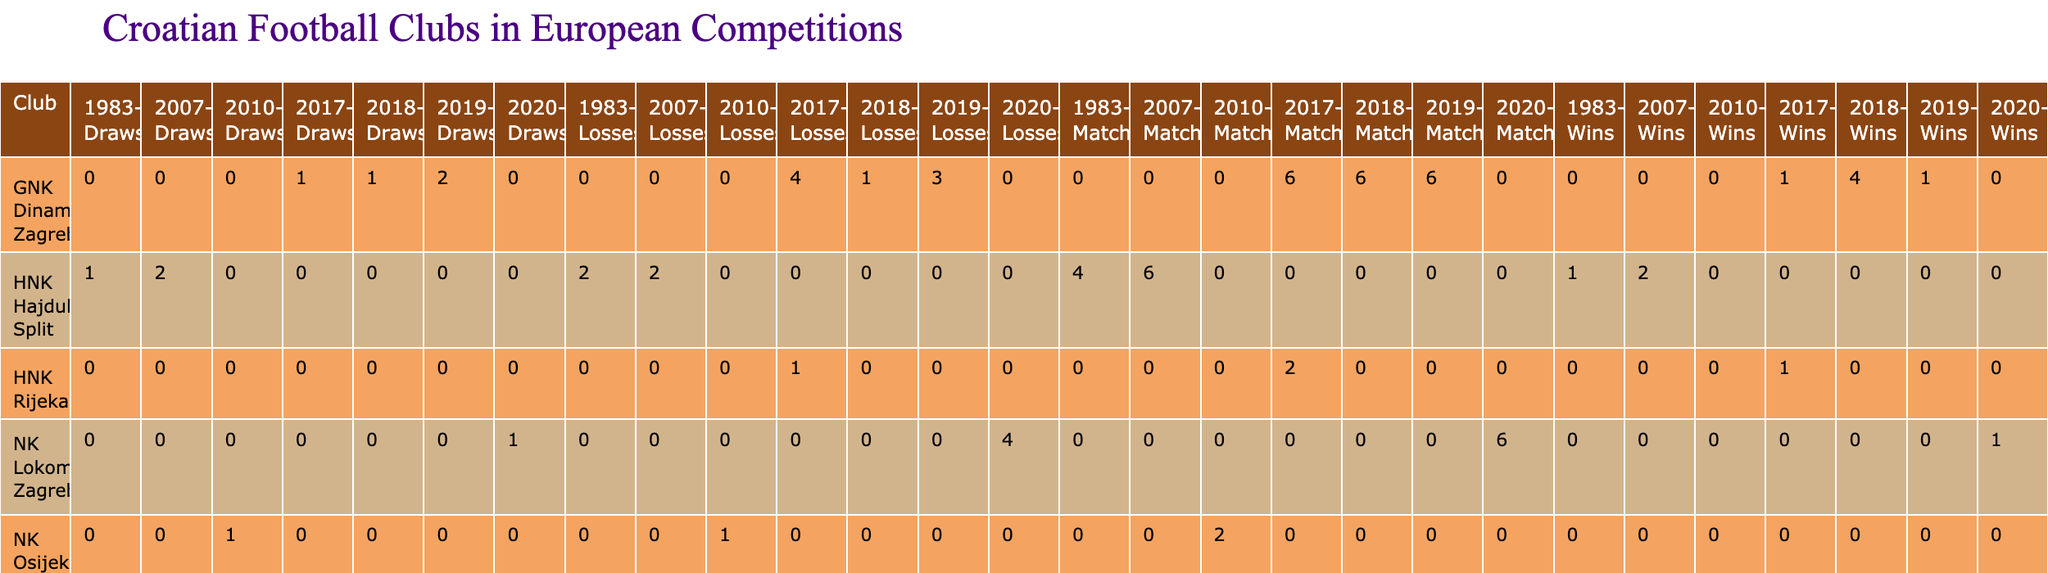What is the total number of matches played by GNK Dinamo Zagreb in the 2018-2019 UEFA Europa League? The table shows that in the 2018-2019 UEFA Europa League, GNK Dinamo Zagreb played a total of 6 matches.
Answer: 6 Which club had the most wins in their group stage matches in the 2019-2020 UEFA Champions League? In the 2019-2020 UEFA Champions League, GNK Dinamo Zagreb had 1 win in the group stage, which is noted in the table. This is the only entry in this specific competition for that season, so there are no clubs with more wins.
Answer: 1 How many total losses did HNK Hajduk Split have across their European competitions in the data presented? The table shows that HNK Hajduk Split had 2 losses in the 2007-2008 UEFA Cup and no other entries, leading to a total of 2 losses overall.
Answer: 2 Is it true that NK Osijek won any matches in their 2010-2011 UEFA Europa League qualification? The table indicates that NK Osijek did not win any matches, as they have 0 wins logged.
Answer: Yes What was the average number of draws for HNK Rijeka in European competitions based on the data? HNK Rijeka played 2 matches in the 2017-2018 UEFA Europa League with 0 draws and no other entries. Therefore, the average is calculated as (0 draws) / (1 competition) = 0.
Answer: 0 How many goals did GNK Dinamo Zagreb score in the UEFA Champions League group stage of 2017-2018 compared to their UEFA Europa League performance in 2018-2019? In the 2017-2018 UEFA Champions League group stage, GNK Dinamo Zagreb scored 4 goals, while in the 2018-2019 UEFA Europa League, they scored 14 goals. Thus, the goals scored in UEFA Europa League is 10 more than that in UEFA Champions League.
Answer: 10 more Which club had the best goal difference in the 2018-2019 UEFA Europa League group stage? In 2018-2019, GNK Dinamo Zagreb scored 14 goals and conceded 5, giving them a goal difference of +9. No other club's goal difference in that competition surpasses this.
Answer: GNK Dinamo Zagreb What was the stage reached by HNK Hajduk Split in the European Cup of 1983-1984? According to the table, HNK Hajduk Split reached the Quarter-Finals stage in the European Cup of 1983-1984.
Answer: Quarter-Finals What is the overall record of HNK Hajduk Split in terms of wins, losses, and draws if we consider their match in the UEFA Cup and European Cup? HNK Hajduk Split had a total of 2 wins, 2 losses, and 2 draws in the UEFA Cup and European Cup matches as per the available data.
Answer: 2 wins, 2 losses, 2 draws 